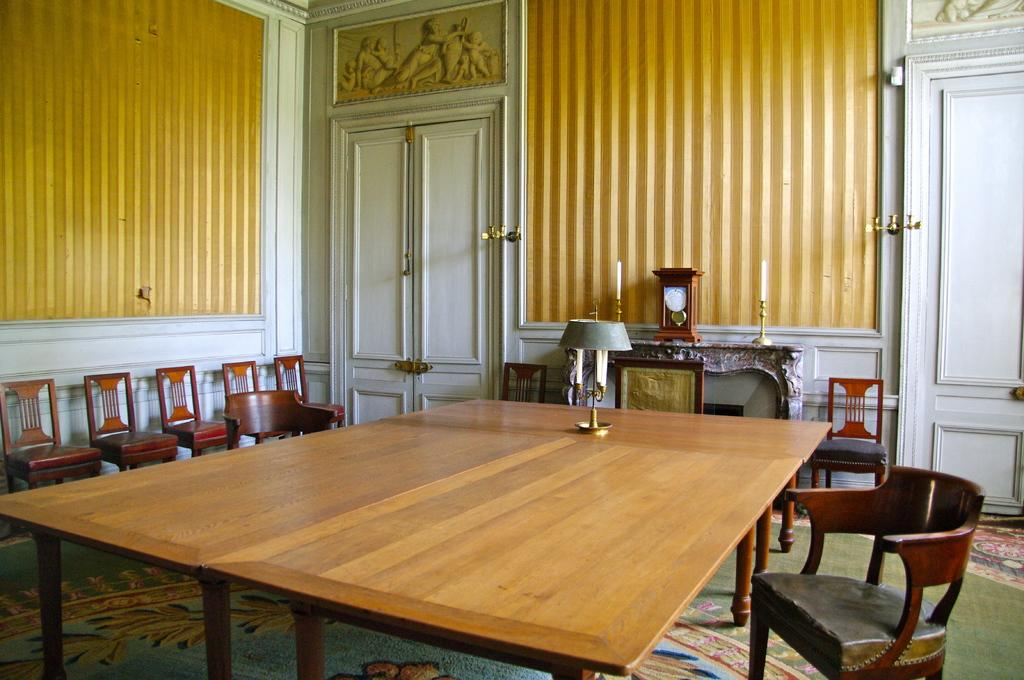What type of setting is shown in the image? The image depicts an inside view of a room. What furniture is present in the room? There are chairs and a table in the room. What is used for illumination in the room? There are lights in the room. How can one enter or exit the room? There are doors in the room. How many matches are on the table in the image? There is no mention of matches in the image, so we cannot determine their presence or quantity. 